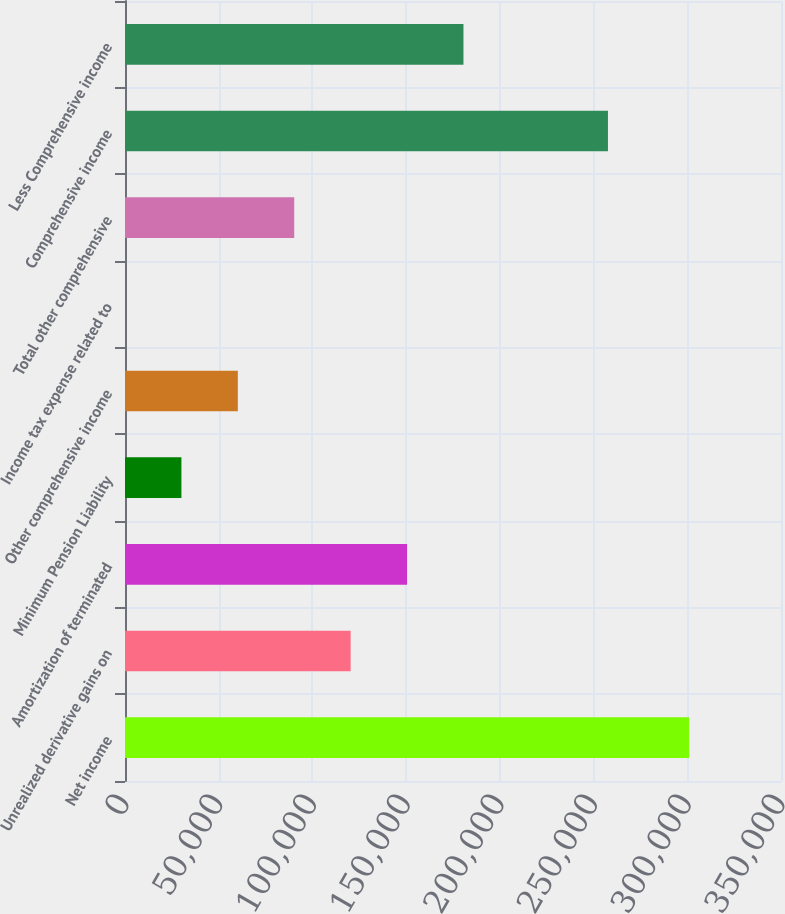<chart> <loc_0><loc_0><loc_500><loc_500><bar_chart><fcel>Net income<fcel>Unrealized derivative gains on<fcel>Amortization of terminated<fcel>Minimum Pension Liability<fcel>Other comprehensive income<fcel>Income tax expense related to<fcel>Total other comprehensive<fcel>Comprehensive income<fcel>Less Comprehensive income<nl><fcel>300970<fcel>120389<fcel>150485<fcel>30097.8<fcel>60194.7<fcel>0.88<fcel>90291.6<fcel>257680<fcel>180582<nl></chart> 